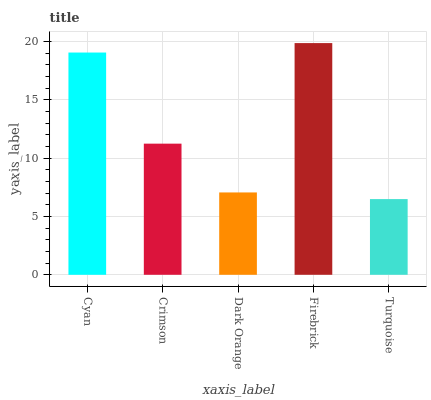Is Turquoise the minimum?
Answer yes or no. Yes. Is Firebrick the maximum?
Answer yes or no. Yes. Is Crimson the minimum?
Answer yes or no. No. Is Crimson the maximum?
Answer yes or no. No. Is Cyan greater than Crimson?
Answer yes or no. Yes. Is Crimson less than Cyan?
Answer yes or no. Yes. Is Crimson greater than Cyan?
Answer yes or no. No. Is Cyan less than Crimson?
Answer yes or no. No. Is Crimson the high median?
Answer yes or no. Yes. Is Crimson the low median?
Answer yes or no. Yes. Is Firebrick the high median?
Answer yes or no. No. Is Dark Orange the low median?
Answer yes or no. No. 